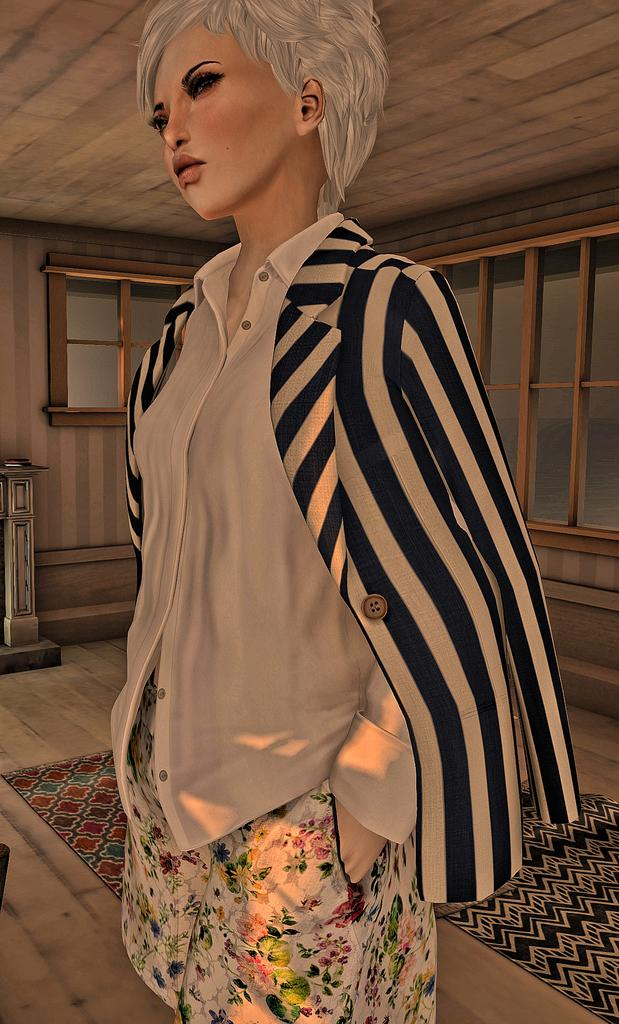What is the main subject of the image? There is a depiction of a scene in the image. Can you describe the woman in the image? A woman is standing in the front of the scene. What can be seen in the background of the image? There are windows visible in the background. What is the unusual object on the floor? There is a mattress on the floor. What type of pest can be seen crawling on the mattress in the image? There are no pests visible in the image, and the mattress is not shown to have any pests on it. 